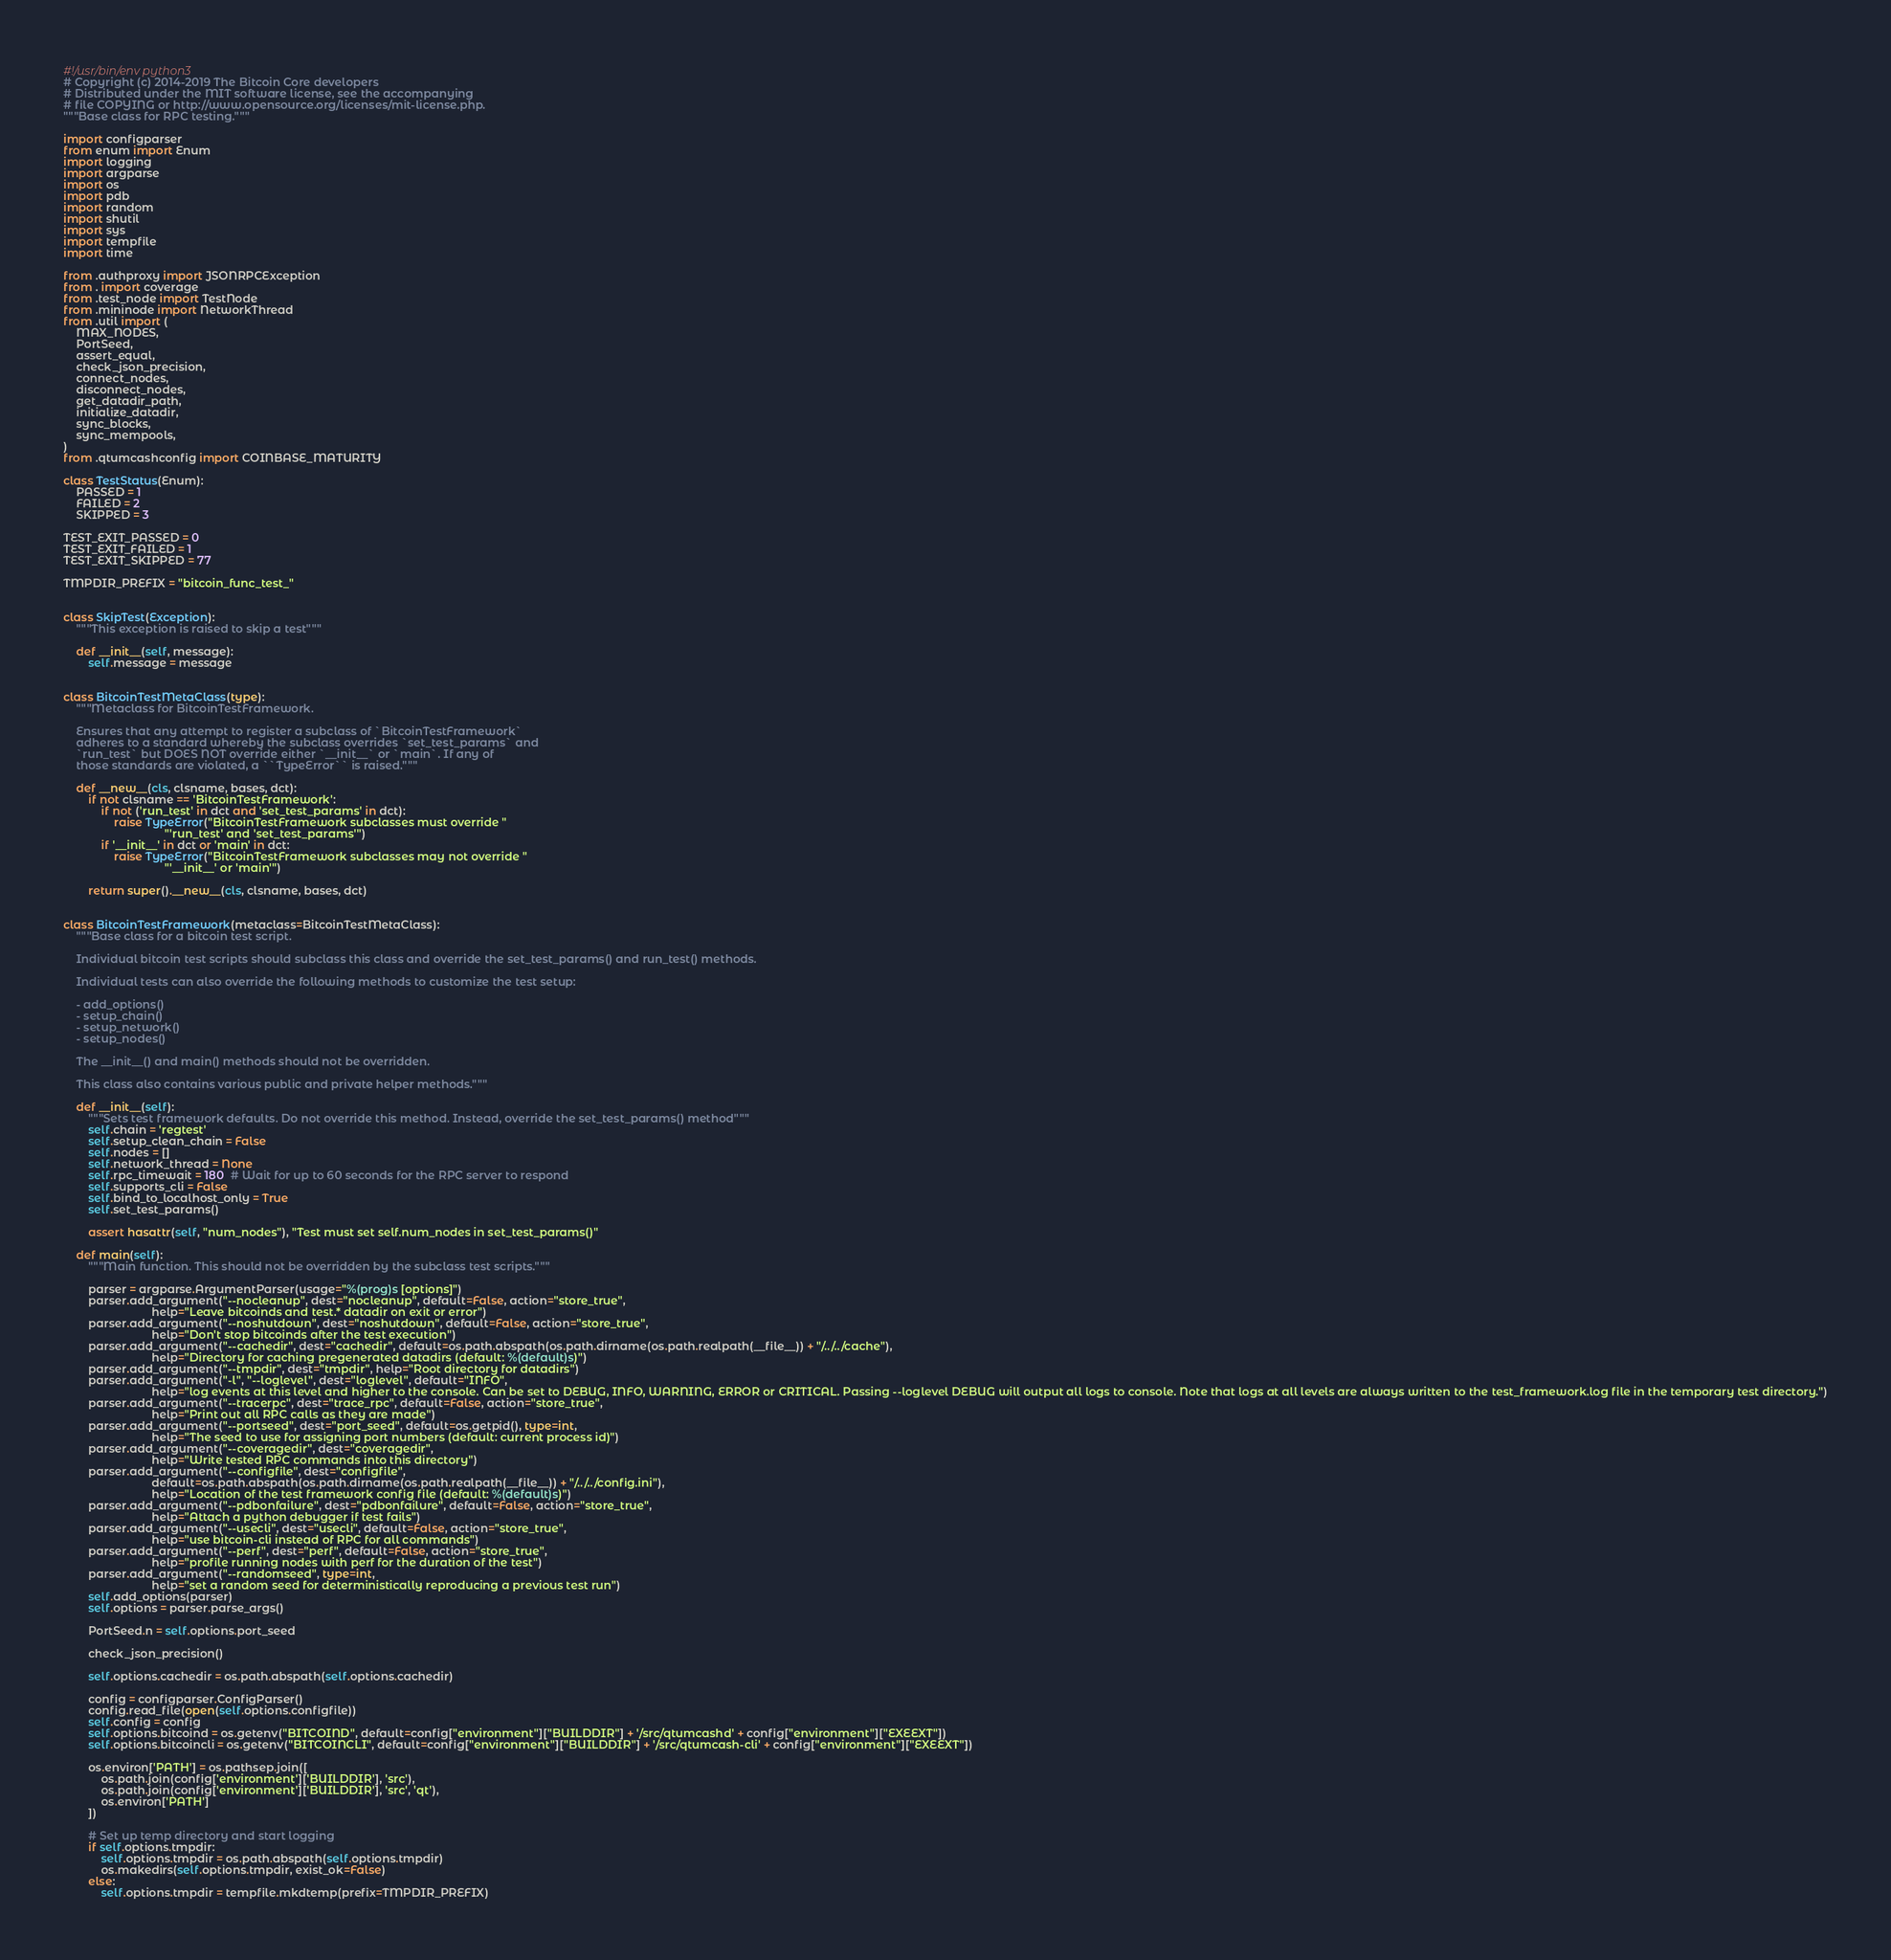Convert code to text. <code><loc_0><loc_0><loc_500><loc_500><_Python_>#!/usr/bin/env python3
# Copyright (c) 2014-2019 The Bitcoin Core developers
# Distributed under the MIT software license, see the accompanying
# file COPYING or http://www.opensource.org/licenses/mit-license.php.
"""Base class for RPC testing."""

import configparser
from enum import Enum
import logging
import argparse
import os
import pdb
import random
import shutil
import sys
import tempfile
import time

from .authproxy import JSONRPCException
from . import coverage
from .test_node import TestNode
from .mininode import NetworkThread
from .util import (
    MAX_NODES,
    PortSeed,
    assert_equal,
    check_json_precision,
    connect_nodes,
    disconnect_nodes,
    get_datadir_path,
    initialize_datadir,
    sync_blocks,
    sync_mempools,
)
from .qtumcashconfig import COINBASE_MATURITY

class TestStatus(Enum):
    PASSED = 1
    FAILED = 2
    SKIPPED = 3

TEST_EXIT_PASSED = 0
TEST_EXIT_FAILED = 1
TEST_EXIT_SKIPPED = 77

TMPDIR_PREFIX = "bitcoin_func_test_"


class SkipTest(Exception):
    """This exception is raised to skip a test"""

    def __init__(self, message):
        self.message = message


class BitcoinTestMetaClass(type):
    """Metaclass for BitcoinTestFramework.

    Ensures that any attempt to register a subclass of `BitcoinTestFramework`
    adheres to a standard whereby the subclass overrides `set_test_params` and
    `run_test` but DOES NOT override either `__init__` or `main`. If any of
    those standards are violated, a ``TypeError`` is raised."""

    def __new__(cls, clsname, bases, dct):
        if not clsname == 'BitcoinTestFramework':
            if not ('run_test' in dct and 'set_test_params' in dct):
                raise TypeError("BitcoinTestFramework subclasses must override "
                                "'run_test' and 'set_test_params'")
            if '__init__' in dct or 'main' in dct:
                raise TypeError("BitcoinTestFramework subclasses may not override "
                                "'__init__' or 'main'")

        return super().__new__(cls, clsname, bases, dct)


class BitcoinTestFramework(metaclass=BitcoinTestMetaClass):
    """Base class for a bitcoin test script.

    Individual bitcoin test scripts should subclass this class and override the set_test_params() and run_test() methods.

    Individual tests can also override the following methods to customize the test setup:

    - add_options()
    - setup_chain()
    - setup_network()
    - setup_nodes()

    The __init__() and main() methods should not be overridden.

    This class also contains various public and private helper methods."""

    def __init__(self):
        """Sets test framework defaults. Do not override this method. Instead, override the set_test_params() method"""
        self.chain = 'regtest'
        self.setup_clean_chain = False
        self.nodes = []
        self.network_thread = None
        self.rpc_timewait = 180  # Wait for up to 60 seconds for the RPC server to respond
        self.supports_cli = False
        self.bind_to_localhost_only = True
        self.set_test_params()

        assert hasattr(self, "num_nodes"), "Test must set self.num_nodes in set_test_params()"

    def main(self):
        """Main function. This should not be overridden by the subclass test scripts."""

        parser = argparse.ArgumentParser(usage="%(prog)s [options]")
        parser.add_argument("--nocleanup", dest="nocleanup", default=False, action="store_true",
                            help="Leave bitcoinds and test.* datadir on exit or error")
        parser.add_argument("--noshutdown", dest="noshutdown", default=False, action="store_true",
                            help="Don't stop bitcoinds after the test execution")
        parser.add_argument("--cachedir", dest="cachedir", default=os.path.abspath(os.path.dirname(os.path.realpath(__file__)) + "/../../cache"),
                            help="Directory for caching pregenerated datadirs (default: %(default)s)")
        parser.add_argument("--tmpdir", dest="tmpdir", help="Root directory for datadirs")
        parser.add_argument("-l", "--loglevel", dest="loglevel", default="INFO",
                            help="log events at this level and higher to the console. Can be set to DEBUG, INFO, WARNING, ERROR or CRITICAL. Passing --loglevel DEBUG will output all logs to console. Note that logs at all levels are always written to the test_framework.log file in the temporary test directory.")
        parser.add_argument("--tracerpc", dest="trace_rpc", default=False, action="store_true",
                            help="Print out all RPC calls as they are made")
        parser.add_argument("--portseed", dest="port_seed", default=os.getpid(), type=int,
                            help="The seed to use for assigning port numbers (default: current process id)")
        parser.add_argument("--coveragedir", dest="coveragedir",
                            help="Write tested RPC commands into this directory")
        parser.add_argument("--configfile", dest="configfile",
                            default=os.path.abspath(os.path.dirname(os.path.realpath(__file__)) + "/../../config.ini"),
                            help="Location of the test framework config file (default: %(default)s)")
        parser.add_argument("--pdbonfailure", dest="pdbonfailure", default=False, action="store_true",
                            help="Attach a python debugger if test fails")
        parser.add_argument("--usecli", dest="usecli", default=False, action="store_true",
                            help="use bitcoin-cli instead of RPC for all commands")
        parser.add_argument("--perf", dest="perf", default=False, action="store_true",
                            help="profile running nodes with perf for the duration of the test")
        parser.add_argument("--randomseed", type=int,
                            help="set a random seed for deterministically reproducing a previous test run")
        self.add_options(parser)
        self.options = parser.parse_args()

        PortSeed.n = self.options.port_seed

        check_json_precision()

        self.options.cachedir = os.path.abspath(self.options.cachedir)

        config = configparser.ConfigParser()
        config.read_file(open(self.options.configfile))
        self.config = config
        self.options.bitcoind = os.getenv("BITCOIND", default=config["environment"]["BUILDDIR"] + '/src/qtumcashd' + config["environment"]["EXEEXT"])
        self.options.bitcoincli = os.getenv("BITCOINCLI", default=config["environment"]["BUILDDIR"] + '/src/qtumcash-cli' + config["environment"]["EXEEXT"])

        os.environ['PATH'] = os.pathsep.join([
            os.path.join(config['environment']['BUILDDIR'], 'src'),
            os.path.join(config['environment']['BUILDDIR'], 'src', 'qt'),
            os.environ['PATH']
        ])

        # Set up temp directory and start logging
        if self.options.tmpdir:
            self.options.tmpdir = os.path.abspath(self.options.tmpdir)
            os.makedirs(self.options.tmpdir, exist_ok=False)
        else:
            self.options.tmpdir = tempfile.mkdtemp(prefix=TMPDIR_PREFIX)</code> 